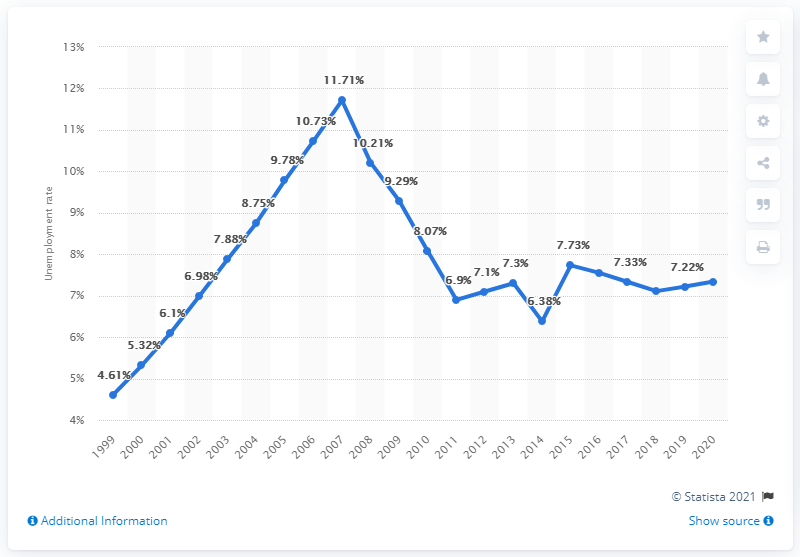Indicate a few pertinent items in this graphic. The unemployment rate in Mali in 2020 was 7.34%. 